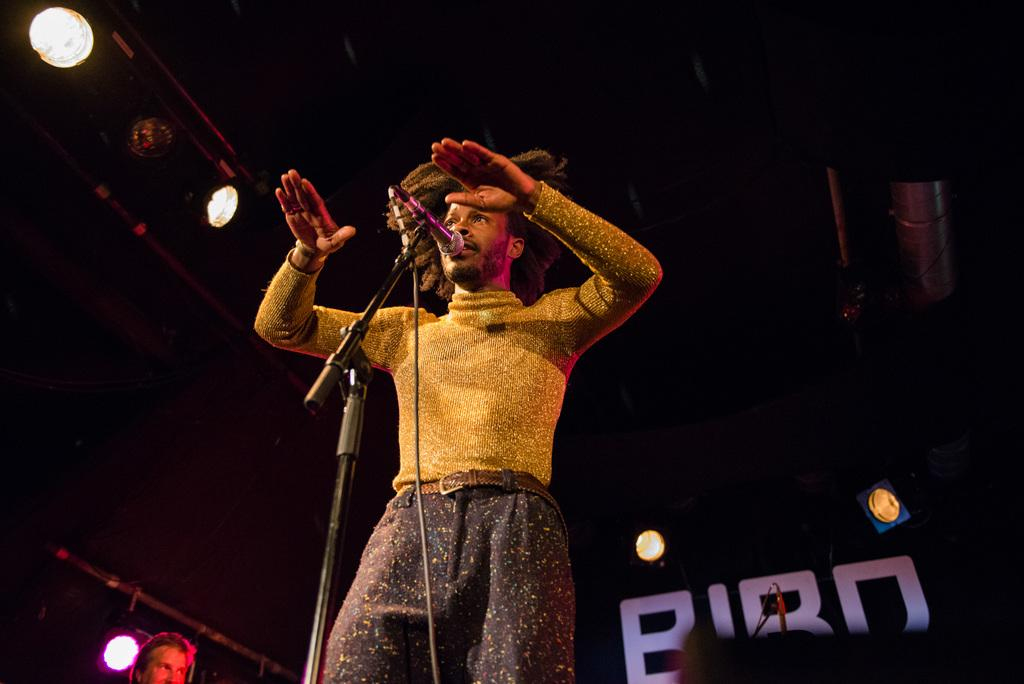What is the main subject of the image? There is a person standing in the image. What object is present near the person? There is a microphone with a stand in the image. What can be seen in the background or surrounding area of the image? There are lights visible in the image. How many pieces of glass can be seen on the floor in the image? There is no glass present on the floor in the image. 